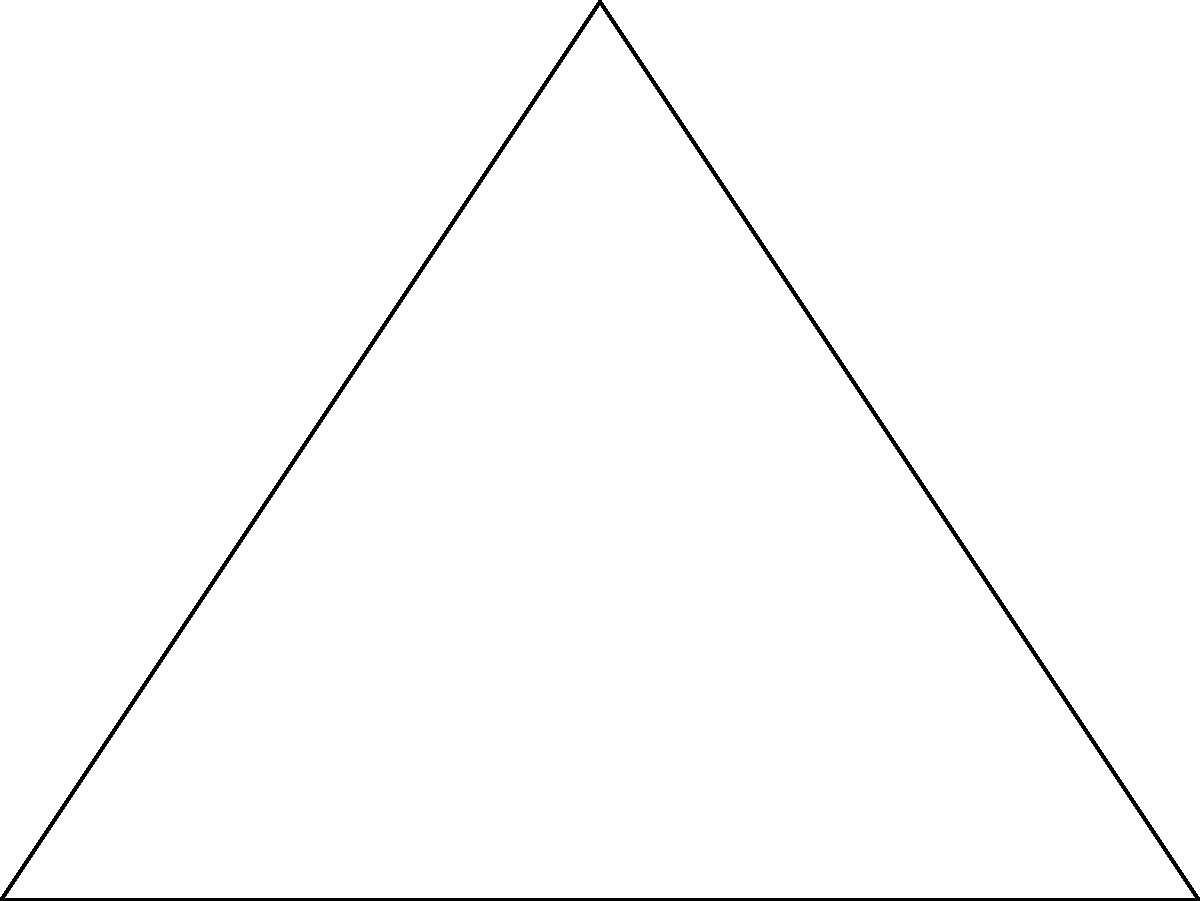As a tour guide planning a hiking trip, you're using a map where congruent circles represent equal travel times between destinations. In the diagram, points A, B, and C represent three tourist spots, and the circles around them show 1-hour travel zones. If the actual distance between A and B is 20 km, what is the approximate distance between A and C in kilometers? Let's approach this step-by-step:

1) First, we need to understand that the congruent circles represent equal travel times, not necessarily equal distances. However, assuming consistent terrain and travel speed, we can use the circles to estimate relative distances.

2) In the diagram, we can see that the triangle ABC is a right-angled triangle, with the right angle at C.

3) We're given that the distance AB is 20 km. This corresponds to 4 units in our diagram (the diameter of two circles).

4) To find AC, we need to find its length in diagram units and then convert to kilometers.

5) In the diagram, AC is the hypotenuse of a right-angled triangle where:
   - The base (AB) is 4 units
   - The height is 3 units (from the top of B's circle to C)

6) We can use the Pythagorean theorem to find AC:

   $AC^2 = 4^2 + 3^2 = 16 + 9 = 25$
   
   $AC = \sqrt{25} = 5$ units

7) Now we need to convert this to kilometers. We know that 4 units = 20 km, so:

   $1 unit = 5 km$

8) Therefore, AC which is 5 units in the diagram is:

   $5 * 5 = 25 km$

Thus, the approximate distance between A and C is 25 km.
Answer: 25 km 